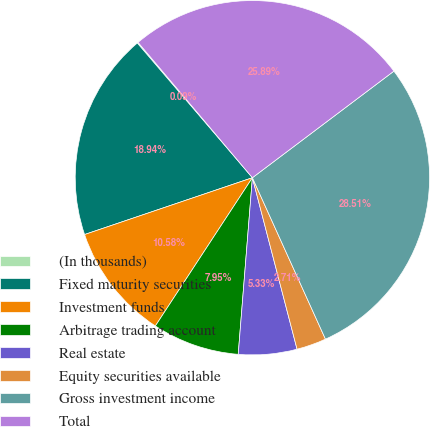<chart> <loc_0><loc_0><loc_500><loc_500><pie_chart><fcel>(In thousands)<fcel>Fixed maturity securities<fcel>Investment funds<fcel>Arbitrage trading account<fcel>Real estate<fcel>Equity securities available<fcel>Gross investment income<fcel>Total<nl><fcel>0.09%<fcel>18.94%<fcel>10.58%<fcel>7.95%<fcel>5.33%<fcel>2.71%<fcel>28.51%<fcel>25.89%<nl></chart> 